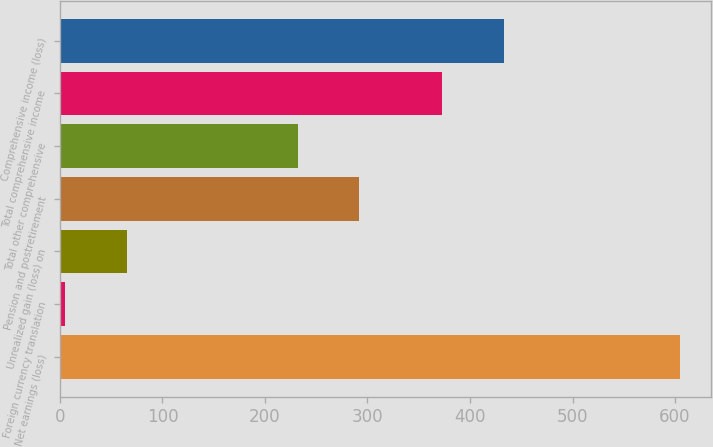Convert chart to OTSL. <chart><loc_0><loc_0><loc_500><loc_500><bar_chart><fcel>Net earnings (loss)<fcel>Foreign currency translation<fcel>Unrealized gain (loss) on<fcel>Pension and postretirement<fcel>Total other comprehensive<fcel>Total comprehensive income<fcel>Comprehensive income (loss)<nl><fcel>605<fcel>5<fcel>65<fcel>292<fcel>232<fcel>373<fcel>433<nl></chart> 